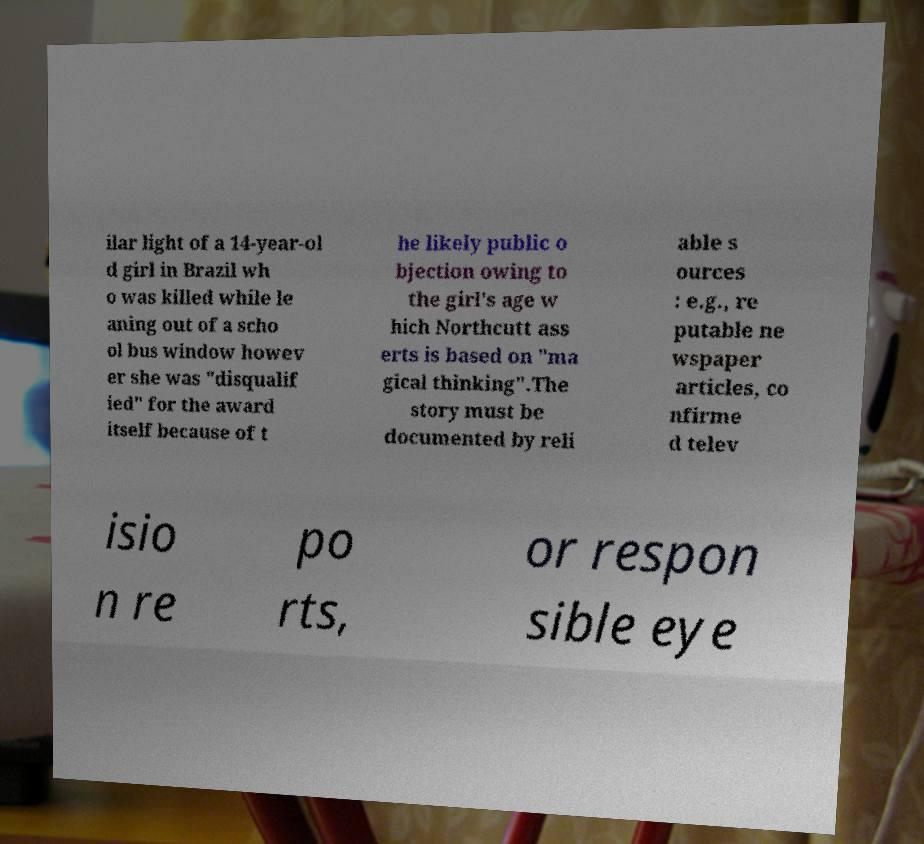Please identify and transcribe the text found in this image. ilar light of a 14-year-ol d girl in Brazil wh o was killed while le aning out of a scho ol bus window howev er she was "disqualif ied" for the award itself because of t he likely public o bjection owing to the girl's age w hich Northcutt ass erts is based on "ma gical thinking".The story must be documented by reli able s ources : e.g., re putable ne wspaper articles, co nfirme d telev isio n re po rts, or respon sible eye 